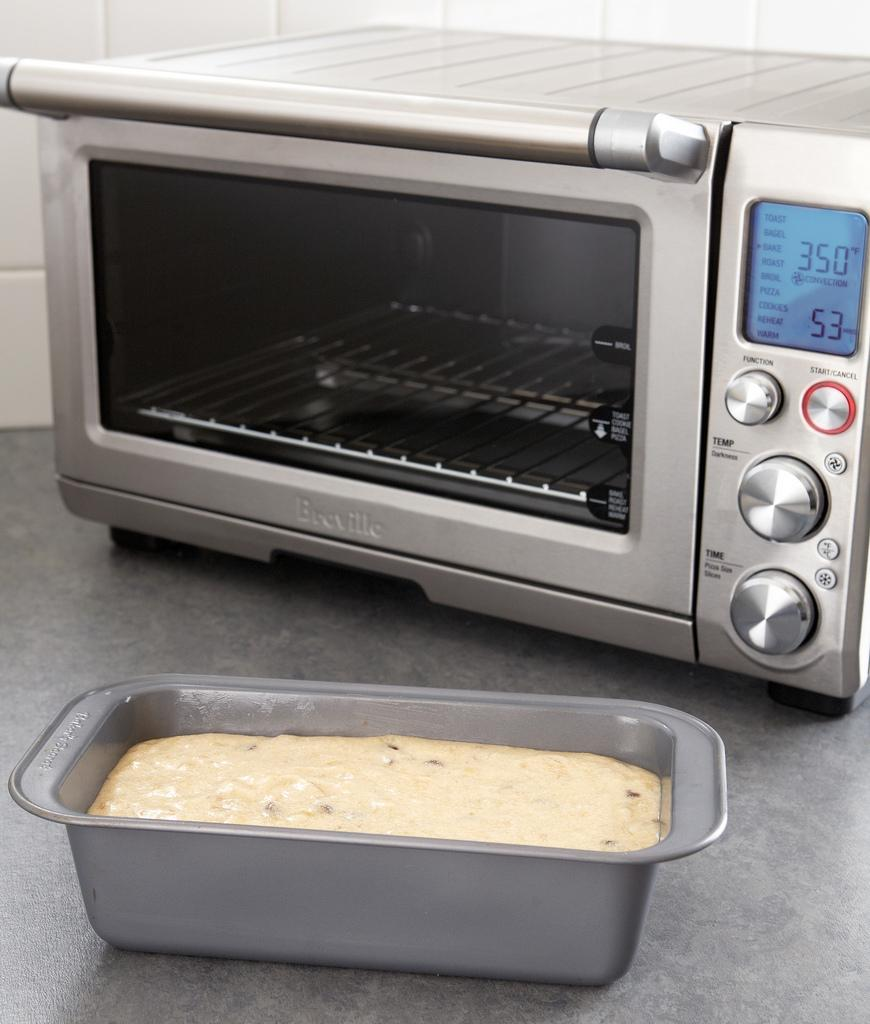<image>
Give a short and clear explanation of the subsequent image. A breadpan sits in front of a toaster oven that displays 350 degrees F convection on its' digital screen. 